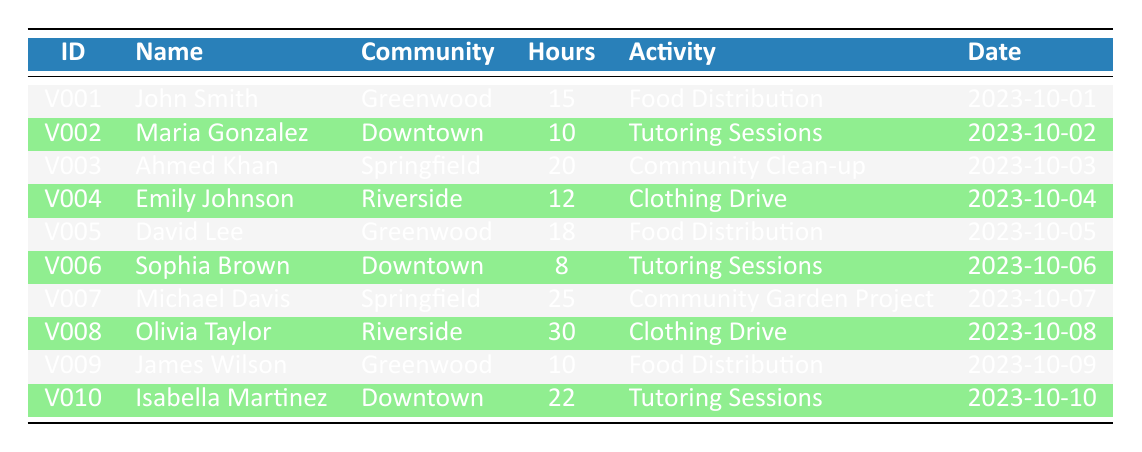What is the total number of hours contributed by volunteers from the Riverside community? There are two volunteers from Riverside: Emily Johnson, who contributed 12 hours, and Olivia Taylor, who contributed 30 hours. Adding these values gives: 12 + 30 = 42 hours.
Answer: 42 Who participated in the Food Distribution activity? Three volunteers participated in Food Distribution: John Smith with 15 hours, David Lee with 18 hours, and James Wilson with 10 hours.
Answer: John Smith, David Lee, James Wilson What is the average number of hours contributed by all volunteers? To find the average, first sum the total hours contributed by all volunteers: 15 + 10 + 20 + 12 + 18 + 8 + 25 + 30 + 10 + 22 =  170 hours. Then, divide this total by the number of volunteers, which is 10. Thus, 170 / 10 = 17 hours.
Answer: 17 Is there any volunteer who contributed more than 25 hours? Yes, there are two volunteers who contributed more than 25 hours: Michael Davis with 25 hours, and Olivia Taylor with 30 hours.
Answer: Yes Which community had the highest single volunteer contribution? Reviewing the hours contributed: Olivia Taylor from Riverside contributed the highest at 30 hours.
Answer: Riverside 